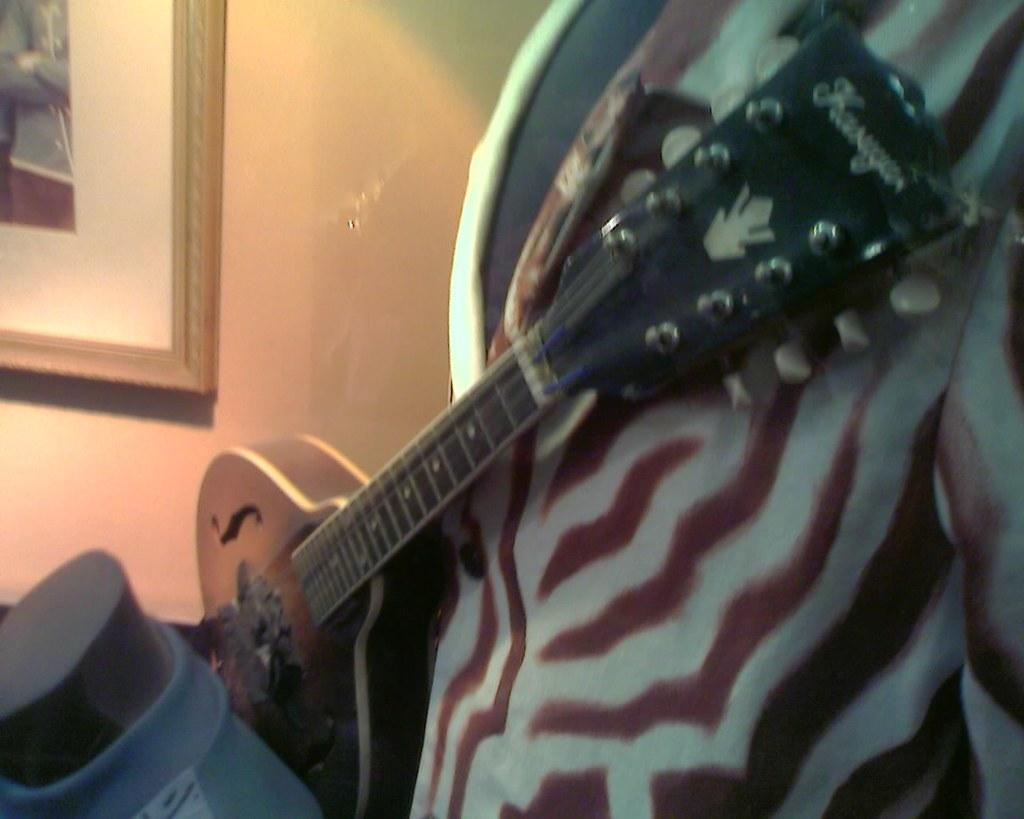What musical instrument is present in the image? There is a guitar in the image. What can be seen on the left side of the image? There is a wall on the left side of the image. What type of seed is being planted in the image? There is no seed or planting activity present in the image; it features a guitar and a wall. What calculator is being used to solve a math problem in the image? There is no calculator or math problem present in the image. 